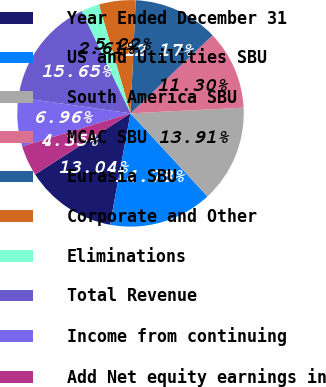<chart> <loc_0><loc_0><loc_500><loc_500><pie_chart><fcel>Year Ended December 31<fcel>US and Utilities SBU<fcel>South America SBU<fcel>MCAC SBU<fcel>Eurasia SBU<fcel>Corporate and Other<fcel>Eliminations<fcel>Total Revenue<fcel>Income from continuing<fcel>Add Net equity earnings in<nl><fcel>13.04%<fcel>14.78%<fcel>13.91%<fcel>11.3%<fcel>12.17%<fcel>5.22%<fcel>2.61%<fcel>15.65%<fcel>6.96%<fcel>4.35%<nl></chart> 